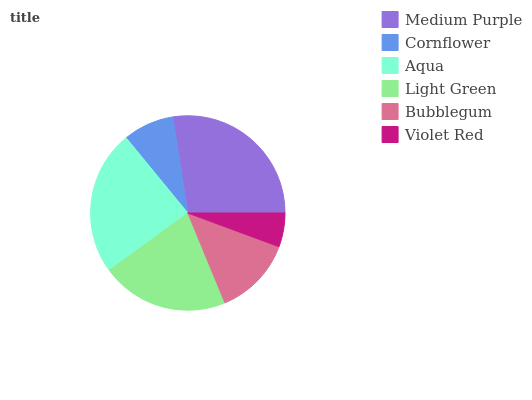Is Violet Red the minimum?
Answer yes or no. Yes. Is Medium Purple the maximum?
Answer yes or no. Yes. Is Cornflower the minimum?
Answer yes or no. No. Is Cornflower the maximum?
Answer yes or no. No. Is Medium Purple greater than Cornflower?
Answer yes or no. Yes. Is Cornflower less than Medium Purple?
Answer yes or no. Yes. Is Cornflower greater than Medium Purple?
Answer yes or no. No. Is Medium Purple less than Cornflower?
Answer yes or no. No. Is Light Green the high median?
Answer yes or no. Yes. Is Bubblegum the low median?
Answer yes or no. Yes. Is Bubblegum the high median?
Answer yes or no. No. Is Medium Purple the low median?
Answer yes or no. No. 